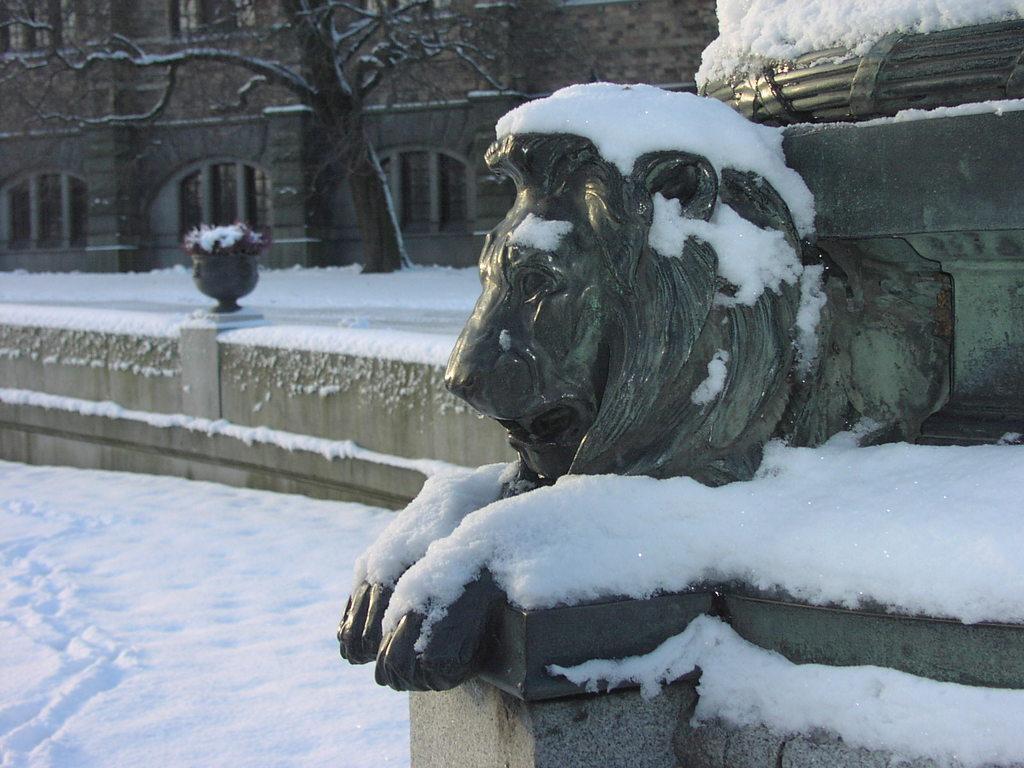How would you summarize this image in a sentence or two? Here we can see statue and snow. Background there is a building, plant, snow and tree. To this building there are windows. 